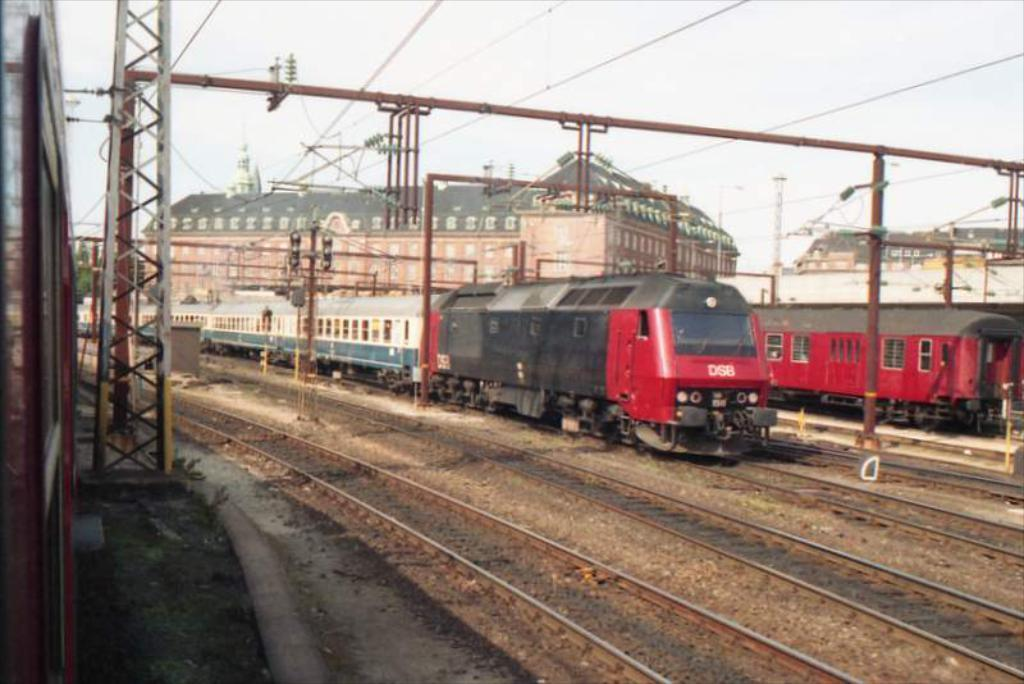What type of vehicles can be seen on the railway tracks in the image? There are trains on the railway tracks in the image. What structures are supporting the wires in the image? Electric poles are visible in the image. What type of structures are present in the image? Buildings are present in the image. What else can be seen in the image besides the trains and buildings? Wires are visible in the image. What is visible in the background of the image? The sky is visible in the background of the image. What type of poison is being used to clean the wires in the image? There is no indication of any poison being used in the image; the wires are simply supported by electric poles. 